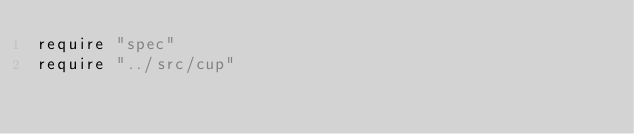Convert code to text. <code><loc_0><loc_0><loc_500><loc_500><_Crystal_>require "spec"
require "../src/cup"
</code> 